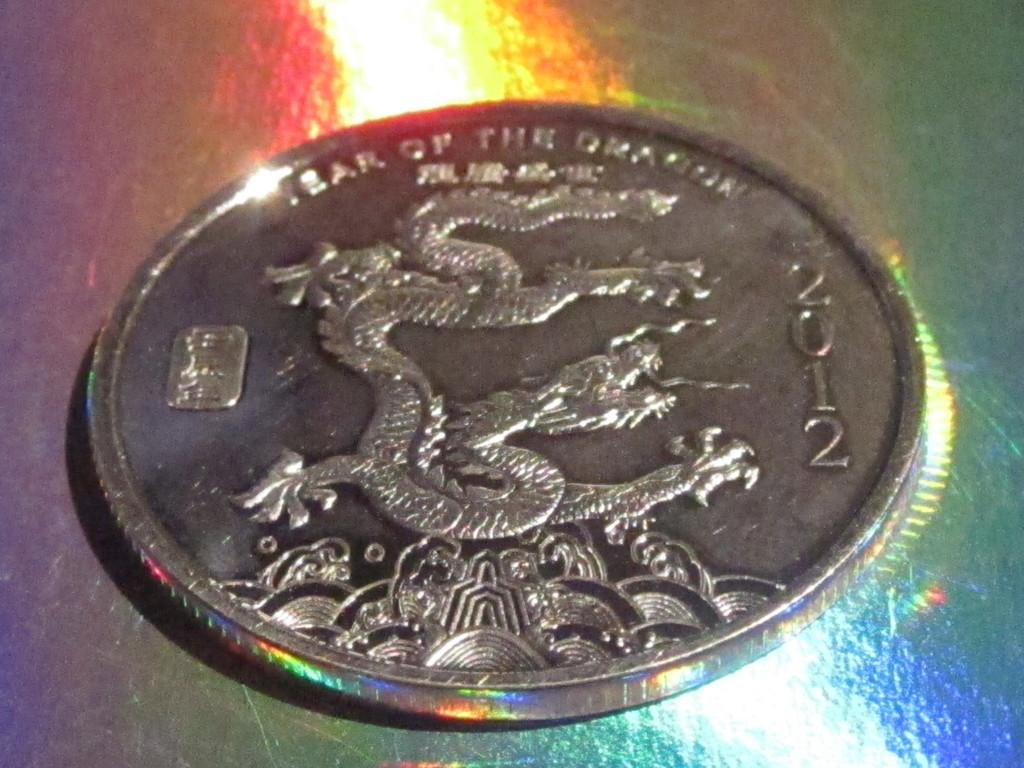Provide a one-sentence caption for the provided image. A 2012 coin that celebrates the year of the dragon. 